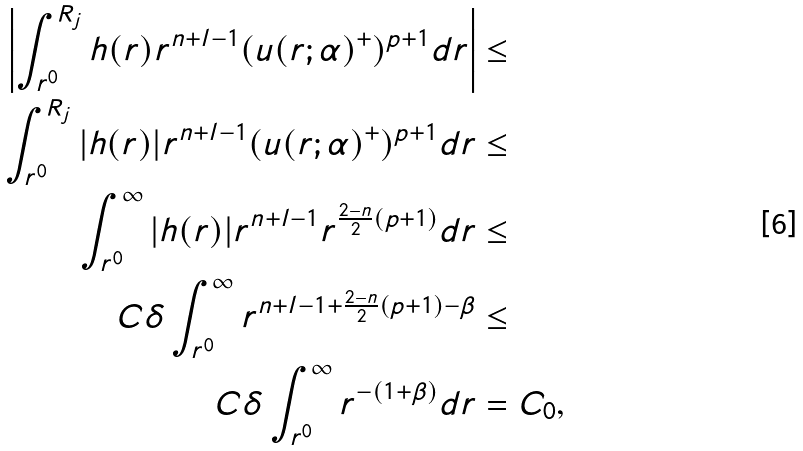<formula> <loc_0><loc_0><loc_500><loc_500>\left | \int _ { r ^ { 0 } } ^ { R _ { j } } h ( r ) r ^ { n + l - 1 } ( u ( r ; \alpha ) ^ { + } ) ^ { p + 1 } d r \right | & \leq \\ \int _ { r ^ { 0 } } ^ { R _ { j } } | h ( r ) | r ^ { n + l - 1 } ( u ( r ; \alpha ) ^ { + } ) ^ { p + 1 } d r & \leq \\ \int _ { r ^ { 0 } } ^ { \infty } | h ( r ) | r ^ { n + l - 1 } r ^ { \frac { 2 - n } { 2 } ( p + 1 ) } d r & \leq \\ C \delta \int _ { r ^ { 0 } } ^ { \infty } r ^ { { n + l - 1 } + \frac { 2 - n } { 2 } ( p + 1 ) - \beta } & \leq \\ C \delta \int _ { r ^ { 0 } } ^ { \infty } r ^ { - ( 1 + \beta ) } d r & = C _ { 0 } ,</formula> 